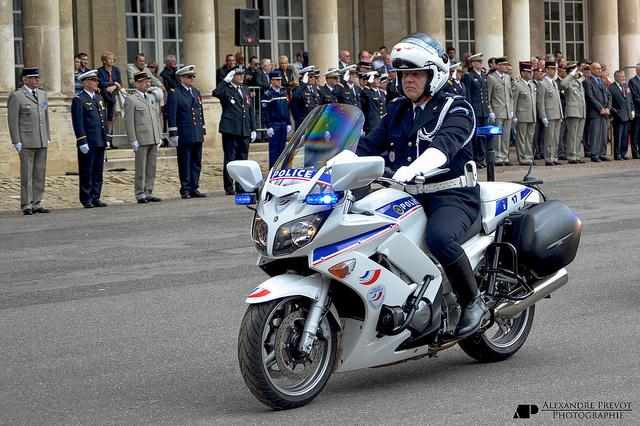Who pays this man's salary?

Choices:
A) private company
B) government
C) religious institution
D) private individual government 